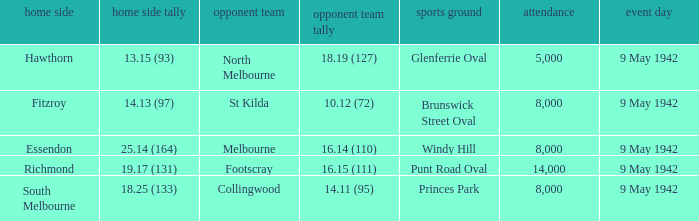Can you parse all the data within this table? {'header': ['home side', 'home side tally', 'opponent team', 'opponent team tally', 'sports ground', 'attendance', 'event day'], 'rows': [['Hawthorn', '13.15 (93)', 'North Melbourne', '18.19 (127)', 'Glenferrie Oval', '5,000', '9 May 1942'], ['Fitzroy', '14.13 (97)', 'St Kilda', '10.12 (72)', 'Brunswick Street Oval', '8,000', '9 May 1942'], ['Essendon', '25.14 (164)', 'Melbourne', '16.14 (110)', 'Windy Hill', '8,000', '9 May 1942'], ['Richmond', '19.17 (131)', 'Footscray', '16.15 (111)', 'Punt Road Oval', '14,000', '9 May 1942'], ['South Melbourne', '18.25 (133)', 'Collingwood', '14.11 (95)', 'Princes Park', '8,000', '9 May 1942']]} How many people attended the game with the home team scoring 18.25 (133)? 1.0. 